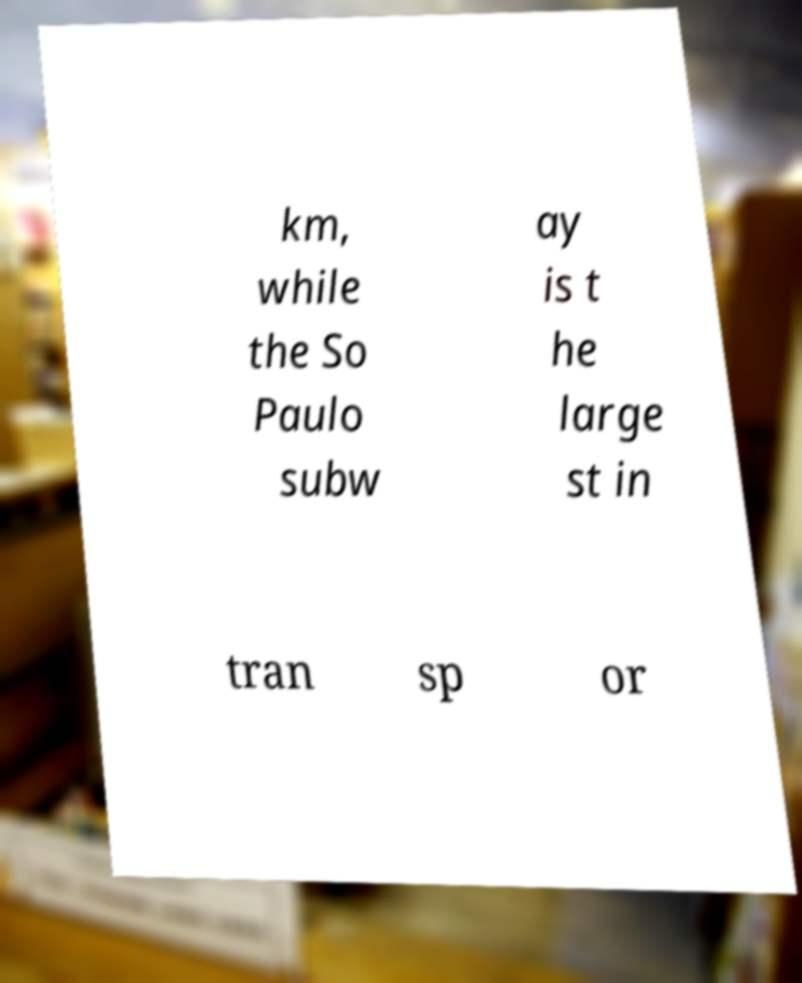Can you accurately transcribe the text from the provided image for me? km, while the So Paulo subw ay is t he large st in tran sp or 